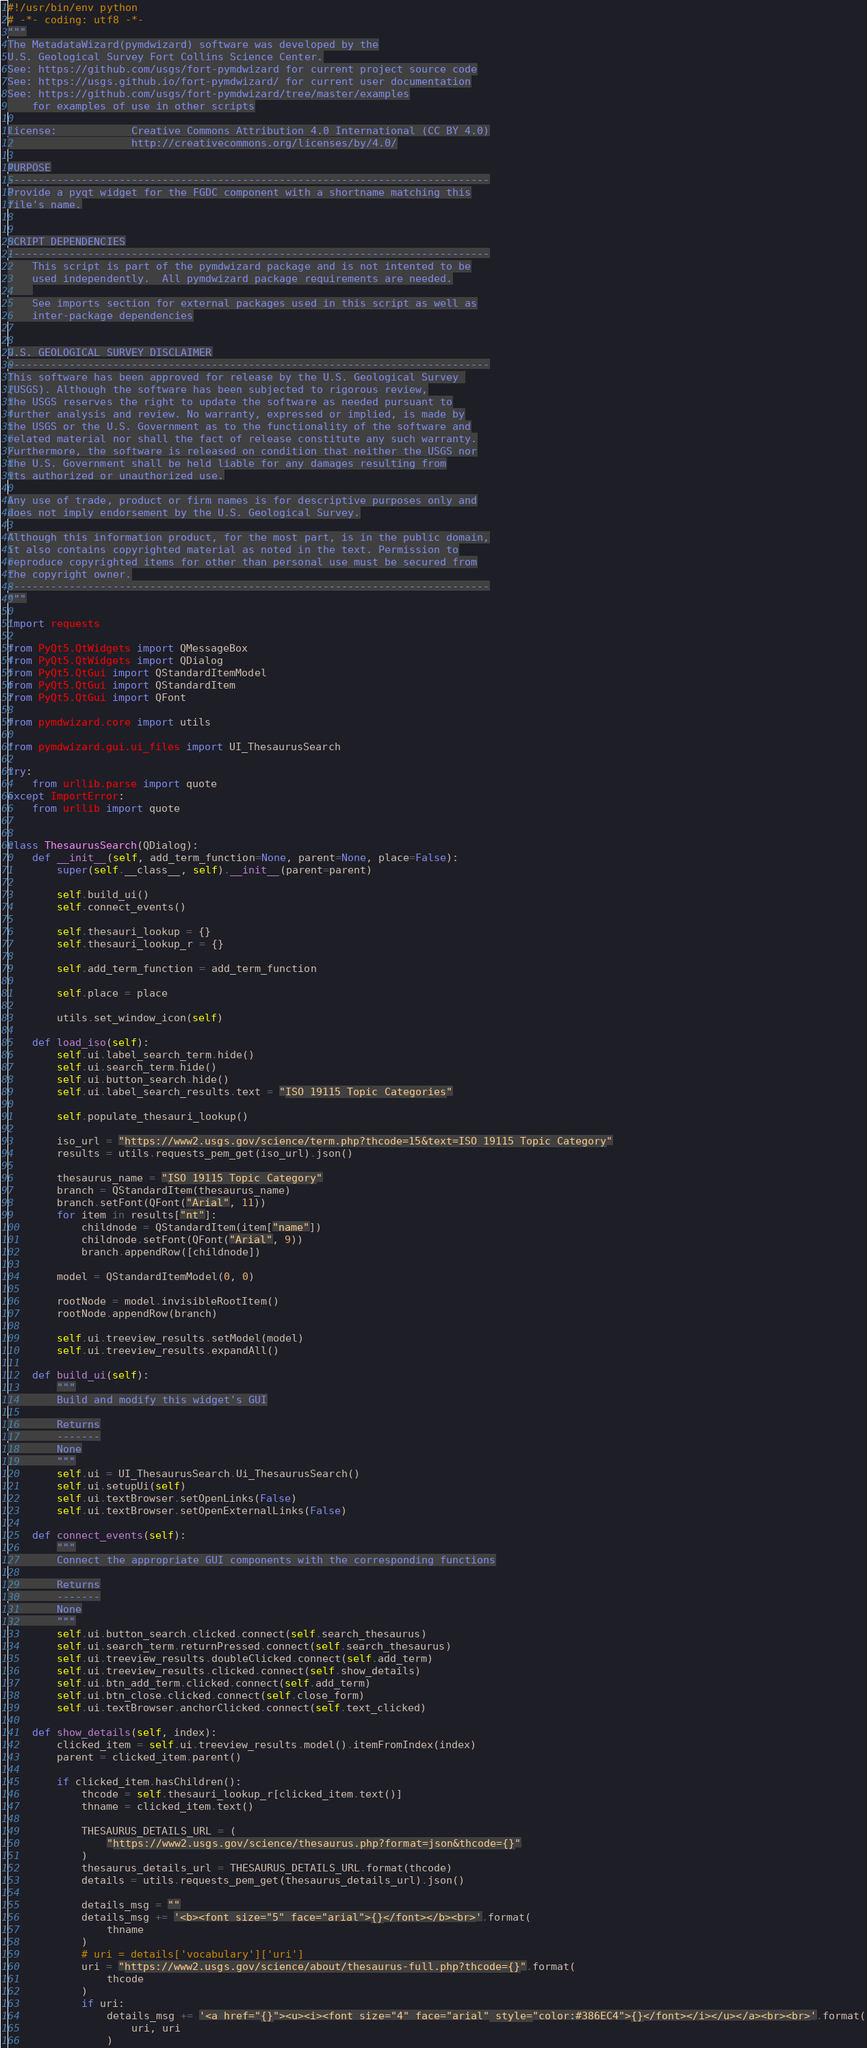Convert code to text. <code><loc_0><loc_0><loc_500><loc_500><_Python_>#!/usr/bin/env python
# -*- coding: utf8 -*-
"""
The MetadataWizard(pymdwizard) software was developed by the
U.S. Geological Survey Fort Collins Science Center.
See: https://github.com/usgs/fort-pymdwizard for current project source code
See: https://usgs.github.io/fort-pymdwizard/ for current user documentation
See: https://github.com/usgs/fort-pymdwizard/tree/master/examples
    for examples of use in other scripts

License:            Creative Commons Attribution 4.0 International (CC BY 4.0)
                    http://creativecommons.org/licenses/by/4.0/

PURPOSE
------------------------------------------------------------------------------
Provide a pyqt widget for the FGDC component with a shortname matching this
file's name.


SCRIPT DEPENDENCIES
------------------------------------------------------------------------------
    This script is part of the pymdwizard package and is not intented to be
    used independently.  All pymdwizard package requirements are needed.
    
    See imports section for external packages used in this script as well as
    inter-package dependencies


U.S. GEOLOGICAL SURVEY DISCLAIMER
------------------------------------------------------------------------------
This software has been approved for release by the U.S. Geological Survey 
(USGS). Although the software has been subjected to rigorous review,
the USGS reserves the right to update the software as needed pursuant to
further analysis and review. No warranty, expressed or implied, is made by
the USGS or the U.S. Government as to the functionality of the software and
related material nor shall the fact of release constitute any such warranty.
Furthermore, the software is released on condition that neither the USGS nor
the U.S. Government shall be held liable for any damages resulting from
its authorized or unauthorized use.

Any use of trade, product or firm names is for descriptive purposes only and
does not imply endorsement by the U.S. Geological Survey.

Although this information product, for the most part, is in the public domain,
it also contains copyrighted material as noted in the text. Permission to
reproduce copyrighted items for other than personal use must be secured from
the copyright owner.
------------------------------------------------------------------------------
"""

import requests

from PyQt5.QtWidgets import QMessageBox
from PyQt5.QtWidgets import QDialog
from PyQt5.QtGui import QStandardItemModel
from PyQt5.QtGui import QStandardItem
from PyQt5.QtGui import QFont

from pymdwizard.core import utils

from pymdwizard.gui.ui_files import UI_ThesaurusSearch

try:
    from urllib.parse import quote
except ImportError:
    from urllib import quote


class ThesaurusSearch(QDialog):
    def __init__(self, add_term_function=None, parent=None, place=False):
        super(self.__class__, self).__init__(parent=parent)

        self.build_ui()
        self.connect_events()

        self.thesauri_lookup = {}
        self.thesauri_lookup_r = {}

        self.add_term_function = add_term_function

        self.place = place

        utils.set_window_icon(self)

    def load_iso(self):
        self.ui.label_search_term.hide()
        self.ui.search_term.hide()
        self.ui.button_search.hide()
        self.ui.label_search_results.text = "ISO 19115 Topic Categories"

        self.populate_thesauri_lookup()

        iso_url = "https://www2.usgs.gov/science/term.php?thcode=15&text=ISO 19115 Topic Category"
        results = utils.requests_pem_get(iso_url).json()

        thesaurus_name = "ISO 19115 Topic Category"
        branch = QStandardItem(thesaurus_name)
        branch.setFont(QFont("Arial", 11))
        for item in results["nt"]:
            childnode = QStandardItem(item["name"])
            childnode.setFont(QFont("Arial", 9))
            branch.appendRow([childnode])

        model = QStandardItemModel(0, 0)

        rootNode = model.invisibleRootItem()
        rootNode.appendRow(branch)

        self.ui.treeview_results.setModel(model)
        self.ui.treeview_results.expandAll()

    def build_ui(self):
        """
        Build and modify this widget's GUI

        Returns
        -------
        None
        """
        self.ui = UI_ThesaurusSearch.Ui_ThesaurusSearch()
        self.ui.setupUi(self)
        self.ui.textBrowser.setOpenLinks(False)
        self.ui.textBrowser.setOpenExternalLinks(False)

    def connect_events(self):
        """
        Connect the appropriate GUI components with the corresponding functions

        Returns
        -------
        None
        """
        self.ui.button_search.clicked.connect(self.search_thesaurus)
        self.ui.search_term.returnPressed.connect(self.search_thesaurus)
        self.ui.treeview_results.doubleClicked.connect(self.add_term)
        self.ui.treeview_results.clicked.connect(self.show_details)
        self.ui.btn_add_term.clicked.connect(self.add_term)
        self.ui.btn_close.clicked.connect(self.close_form)
        self.ui.textBrowser.anchorClicked.connect(self.text_clicked)

    def show_details(self, index):
        clicked_item = self.ui.treeview_results.model().itemFromIndex(index)
        parent = clicked_item.parent()

        if clicked_item.hasChildren():
            thcode = self.thesauri_lookup_r[clicked_item.text()]
            thname = clicked_item.text()

            THESAURUS_DETAILS_URL = (
                "https://www2.usgs.gov/science/thesaurus.php?format=json&thcode={}"
            )
            thesaurus_details_url = THESAURUS_DETAILS_URL.format(thcode)
            details = utils.requests_pem_get(thesaurus_details_url).json()

            details_msg = ""
            details_msg += '<b><font size="5" face="arial">{}</font></b><br>'.format(
                thname
            )
            # uri = details['vocabulary']['uri']
            uri = "https://www2.usgs.gov/science/about/thesaurus-full.php?thcode={}".format(
                thcode
            )
            if uri:
                details_msg += '<a href="{}"><u><i><font size="4" face="arial" style="color:#386EC4">{}</font></i></u></a><br><br>'.format(
                    uri, uri
                )
</code> 